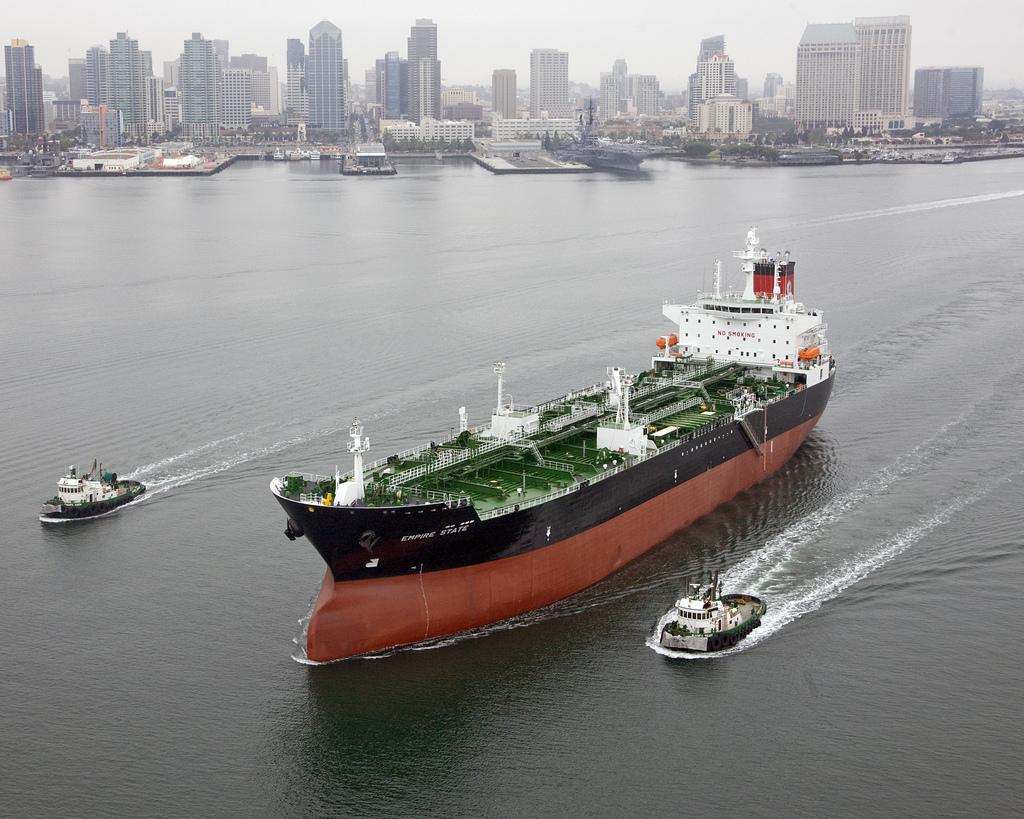What is the main subject of the image? The main subject of the image is a ship. Are there any other watercraft in the image? Yes, there are boats in the image. Where are the ship and boats located? The ship and boats are on the water. What can be seen in the background of the image? In the background of the image, there are buildings, trees, some unspecified objects, and the sky. What type of chain can be seen connecting the ship to the action in the image? There is no chain or action present in the image; it features a ship and boats on the water with a background of buildings, trees, unspecified objects, and the sky. 